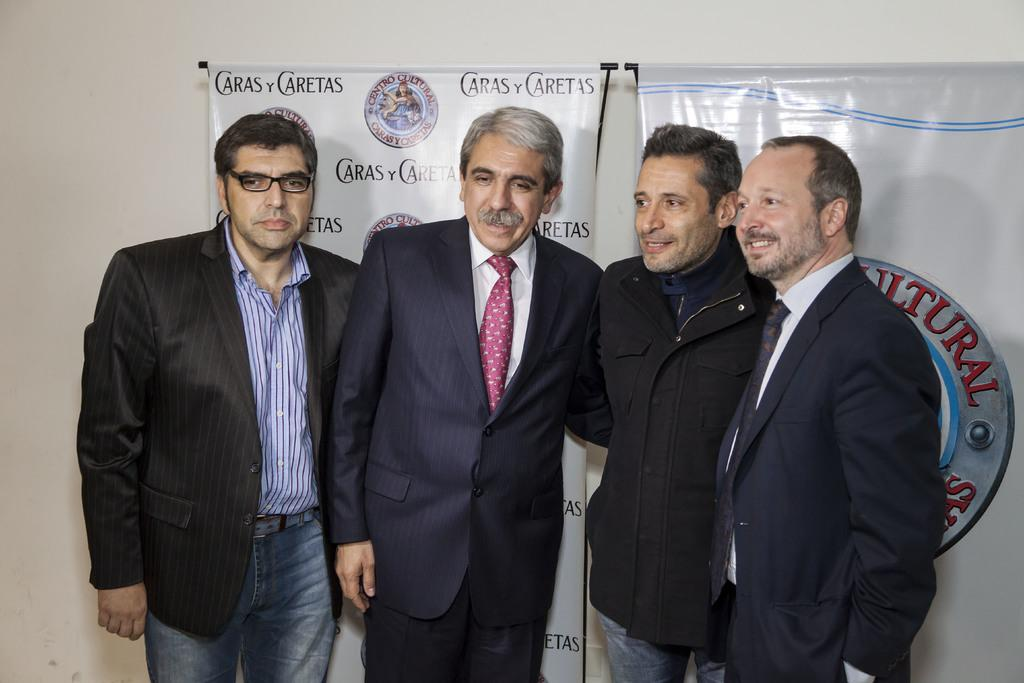How many people are present in the image? There are four persons standing in the image. What can be seen hanging in the image? There are banners in the image. What is visible in the background of the image? There is a wall in the background of the image. What is the level of pollution in the image? There is no information about pollution in the image, as it focuses on the four persons and the banners. 